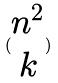Convert formula to latex. <formula><loc_0><loc_0><loc_500><loc_500>( \begin{matrix} n ^ { 2 } \\ k \end{matrix} )</formula> 